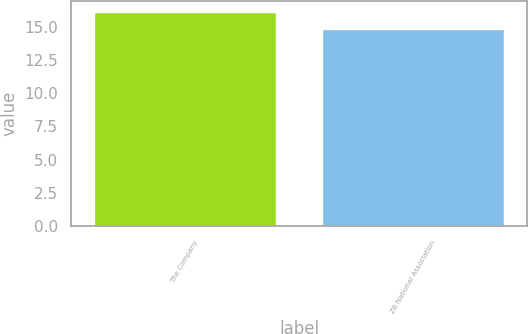<chart> <loc_0><loc_0><loc_500><loc_500><bar_chart><fcel>The Company<fcel>ZB National Association<nl><fcel>16.12<fcel>14.84<nl></chart> 